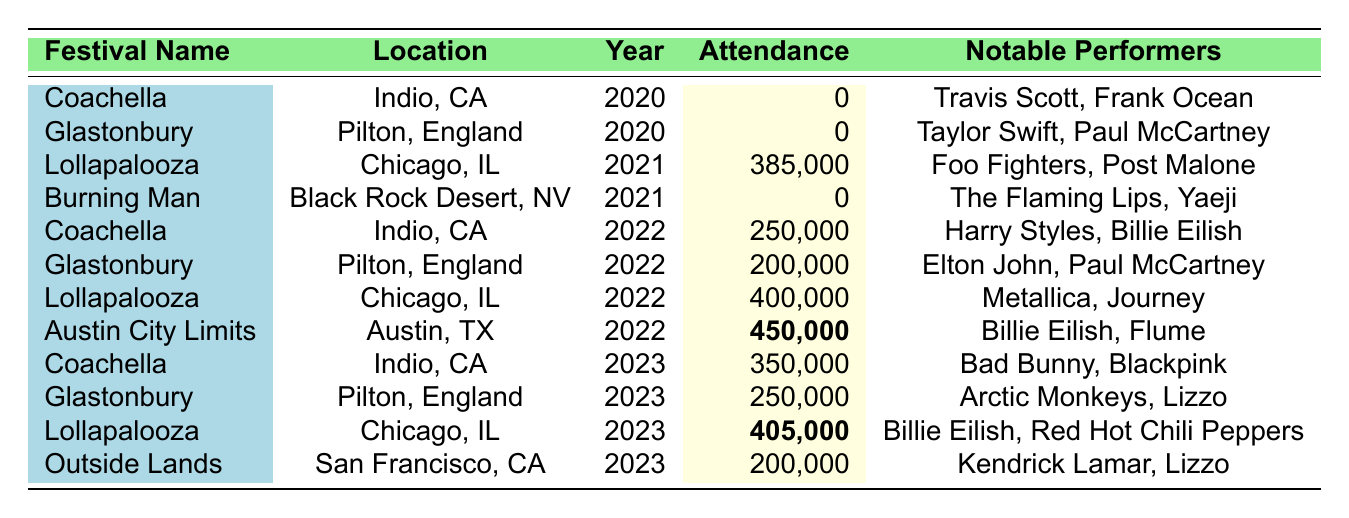What was the attendance at the Coachella festival in 2022? The table shows the attendance for Coachella in 2022 as 250,000.
Answer: 250,000 How many notable performers were listed for the Glastonbury Festival in 2023? In the table for Glastonbury Festival in 2023, there are three notable performers listed: Arctic Monkeys, Lizzo, and Lana Del Rey.
Answer: 3 Which festival had the highest attendance in 2022? According to the table, Austin City Limits had the highest attendance in 2022 with 450,000.
Answer: Austin City Limits What was the total attendance for Lollapalooza across all years? Adding the attendance figures for Lollapalooza: 385,000 (2021) + 400,000 (2022) + 405,000 (2023) = 1,190,000.
Answer: 1,190,000 Is it true that the attendance for Burning Man was more than zero in 2021? The table clearly states that the attendance for Burning Man in 2021 was 0, so this statement is false.
Answer: No What is the average attendance of music festivals listed for the year 2023? The attendance figures for 2023 are: Coachella (350,000), Glastonbury (250,000), Lollapalooza (405,000), and Outside Lands (200,000). The average is calculated as (350,000 + 250,000 + 405,000 + 200,000) / 4 = 301,250.
Answer: 301,250 Which festival had notable performers including Billie Eilish in both 2022 and 2023? The table shows that Billie Eilish was a notable performer at the Austin City Limits festival in 2022 and at Lollapalooza in 2023. Therefore, the festival that includes both years with Billie Eilish is Lollapalooza.
Answer: Lollapalooza How does the attendance in 2023 compare to that in 2021 for the Lollapalooza festival? The attendance for Lollapalooza in 2021 was 385,000 and in 2023 was 405,000. To compare: 405,000 - 385,000 = 20,000, indicating that there was an increase of 20,000 attendees from 2021 to 2023.
Answer: Increased by 20,000 What was the total attendance for all festivals listed in 2020? The attendance figures for festivals in 2020 are: Coachella (0) and Glastonbury (0). Adding these gives us a total of 0.
Answer: 0 Which year saw the largest difference between the highest and lowest attendance figures across all festivals? Analyzing the attendance numbers: the highest is 450,000 (Austin City Limits in 2022) and the lowest is 0 (various festivals in 2020 and 2021). The difference is 450,000 - 0 = 450,000, which indicates that 2022 saw the largest difference when comparing the highest and lowest attendance figures.
Answer: 450,000 